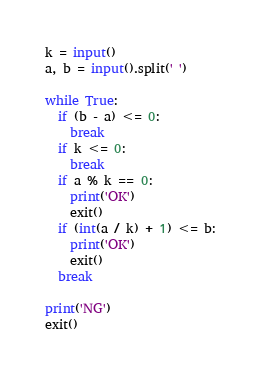Convert code to text. <code><loc_0><loc_0><loc_500><loc_500><_Python_>k = input()
a, b = input().split(' ')

while True:
  if (b - a) <= 0:
    break
  if k <= 0:
    break
  if a % k == 0:
    print('OK')
    exit()
  if (int(a / k) + 1) <= b:
    print('OK')
    exit()
  break

print('NG')
exit()</code> 